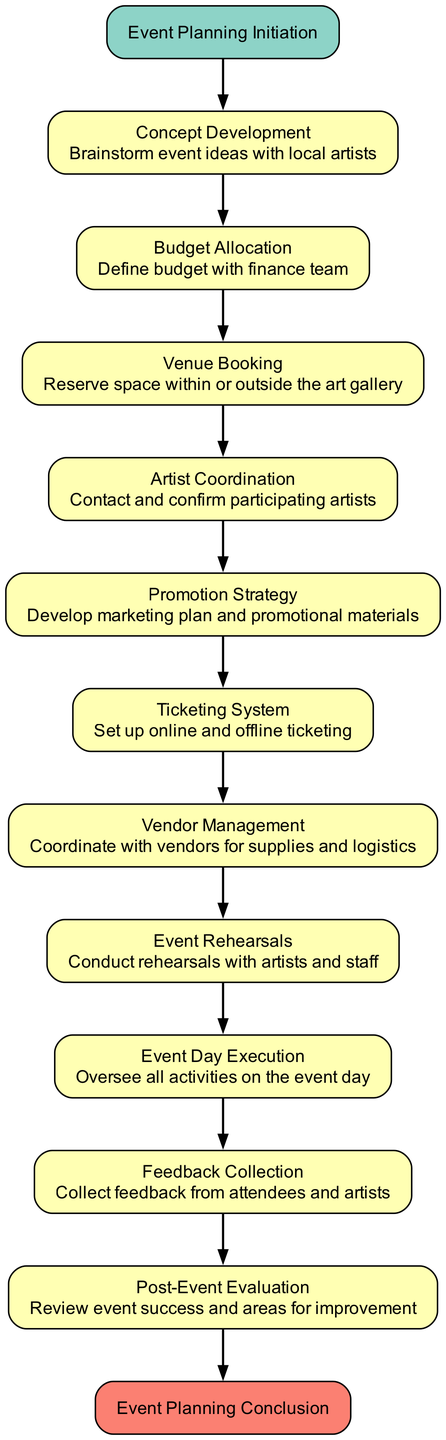What is the first step in the event planning workflow? The first step in the diagram is labeled "Event Planning Initiation," indicating that it is the starting point of the workflow.
Answer: Event Planning Initiation How many total processes are included in the diagram? By counting each process box in the diagram, we find there are eleven processes listed, including concept development, budget allocation, etc.
Answer: Eleven What is the last step before the event planning conclusion? The last step before concluding the workflow is labeled "Post-Event Evaluation," which reviews the event's success and areas for improvement.
Answer: Post-Event Evaluation Which step comes immediately after "Artist Coordination"? The step that follows "Artist Coordination" in the flowchart is "Promotion Strategy." This indicates that after coordinating with artists, the next task is promotional planning.
Answer: Promotion Strategy How many connections are depicted in the workflow? The diagram shows ten connections between the various elements, linking each step to the next in a sequential manner.
Answer: Ten What is the main purpose of the "Feedback Collection" step? The purpose of "Feedback Collection" is to gather responses from attendees and artists to evaluate their experience, contributing to the improvement of future events.
Answer: Collect feedback Which two steps are directly connected without any processes between them? "Event Day Execution" and "Feedback Collection" are connected directly, showing a clear transition from executing the event to collecting feedback afterwards.
Answer: Event Day Execution and Feedback Collection What is the color representing the "Process" type in the diagram? The color assigned to the "Process" type in the diagram is a light yellow (#FFFFB3), which visually distinguishes these steps from the start and end nodes.
Answer: Light yellow What is the specific action described in the "Venue Booking" step? The action specified in "Venue Booking" is to reserve space within or outside the art gallery, indicating the need to secure a location for the event.
Answer: Reserve space 